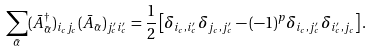<formula> <loc_0><loc_0><loc_500><loc_500>\sum _ { \bar { \alpha } } ( \bar { A } ^ { \dagger } _ { \bar { \alpha } } ) _ { i _ { c } j _ { c } } ( \bar { A } _ { \bar { \alpha } } ) _ { j _ { c } ^ { \prime } i _ { c } ^ { \prime } } = \frac { 1 } { 2 } \left [ \delta _ { i _ { c } , i ^ { \prime } _ { c } } \delta _ { j _ { c } , j ^ { \prime } _ { c } } - ( - 1 ) ^ { p } \delta _ { i _ { c } , j ^ { \prime } _ { c } } \delta _ { i ^ { \prime } _ { c } , j _ { c } } \right ] .</formula> 